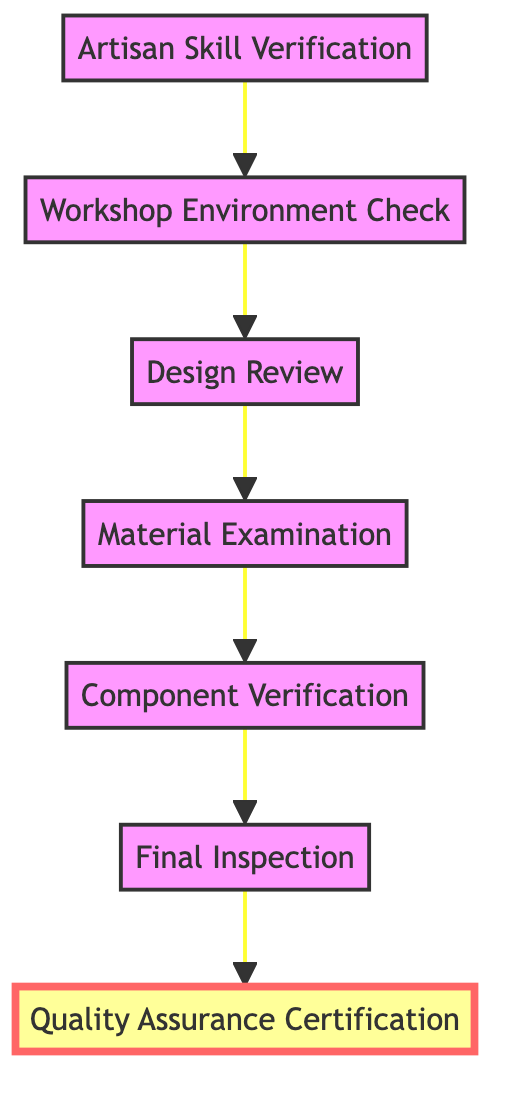What is the first step in the Quality Assurance Procedure? The diagram indicates that the first step in the Quality Assurance Procedure is "Artisan Skill Verification." This is the first node encountered when following the flow from bottom to up.
Answer: Artisan Skill Verification How many nodes are present in the Quality Assurance Procedure flowchart? By counting each distinct step provided in the flowchart, there are a total of 7 nodes, from "Artisan Skill Verification" to "Quality Assurance Certification."
Answer: 7 What is the final step in the procedure? As per the flowchart, the final step is "Quality Assurance Certification," which is the last node at the top of the flow.
Answer: Quality Assurance Certification Which two steps directly follow the Design Review? Following the flowchart, the step "Material Examination" directly follows "Design Review," and the subsequent step after that is "Component Verification."
Answer: Material Examination, Component Verification What is verified before the assembly of furniture components? The flowchart specifies that "Component Verification" is the step that occurs before assembly, where components are checked for accuracy, durability, and finish.
Answer: Component Verification What does the Final Inspection involve? According to the flowchart, "Final Inspection" is described as a comprehensive check for final products that includes visual inspection and functional testing.
Answer: Visual inspection and functional testing Which step emphasizes the workshop conditions? The step that focuses on the workshop conditions is "Workshop Environment Check," which ensures that standards for temperature, humidity, and cleanliness are met.
Answer: Workshop Environment Check What is the purpose of Material Examination? The "Material Examination" step is intended to inspect raw materials for quality, defects, and suitability for the intended use, serving as a critical quality assurance measure.
Answer: Inspect raw materials for quality and defects What happens if artisans do not meet the company's quality standards? If artisans fail to meet the required quality standards during the "Artisan Skill Verification," it implies that they may not proceed to the subsequent steps in the quality assurance process.
Answer: They may not proceed 